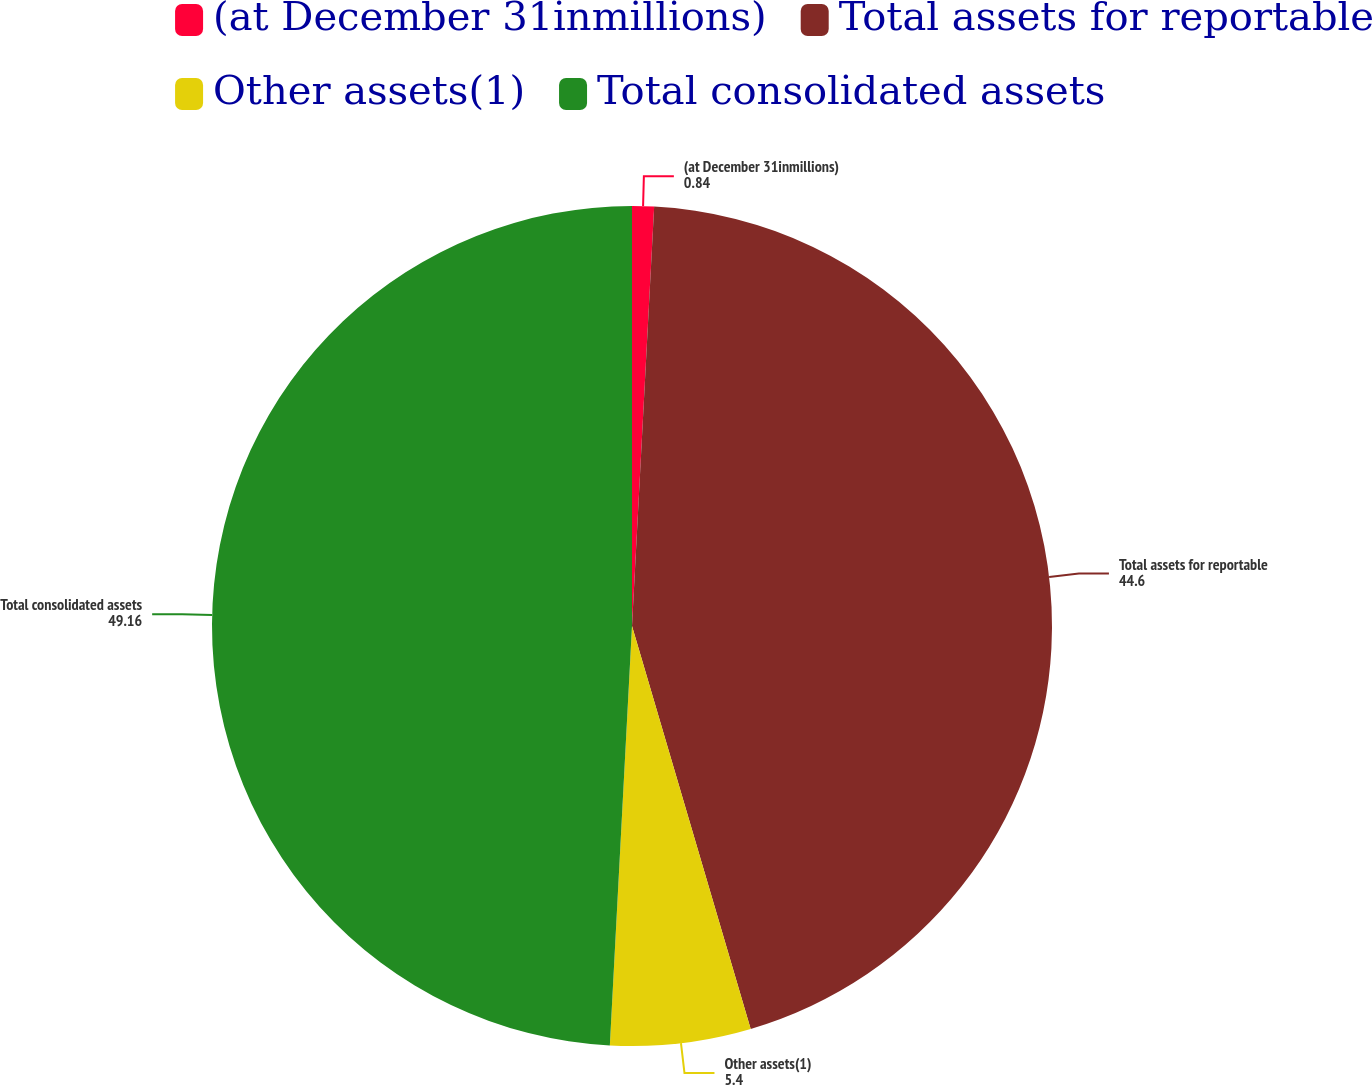<chart> <loc_0><loc_0><loc_500><loc_500><pie_chart><fcel>(at December 31inmillions)<fcel>Total assets for reportable<fcel>Other assets(1)<fcel>Total consolidated assets<nl><fcel>0.84%<fcel>44.6%<fcel>5.4%<fcel>49.16%<nl></chart> 